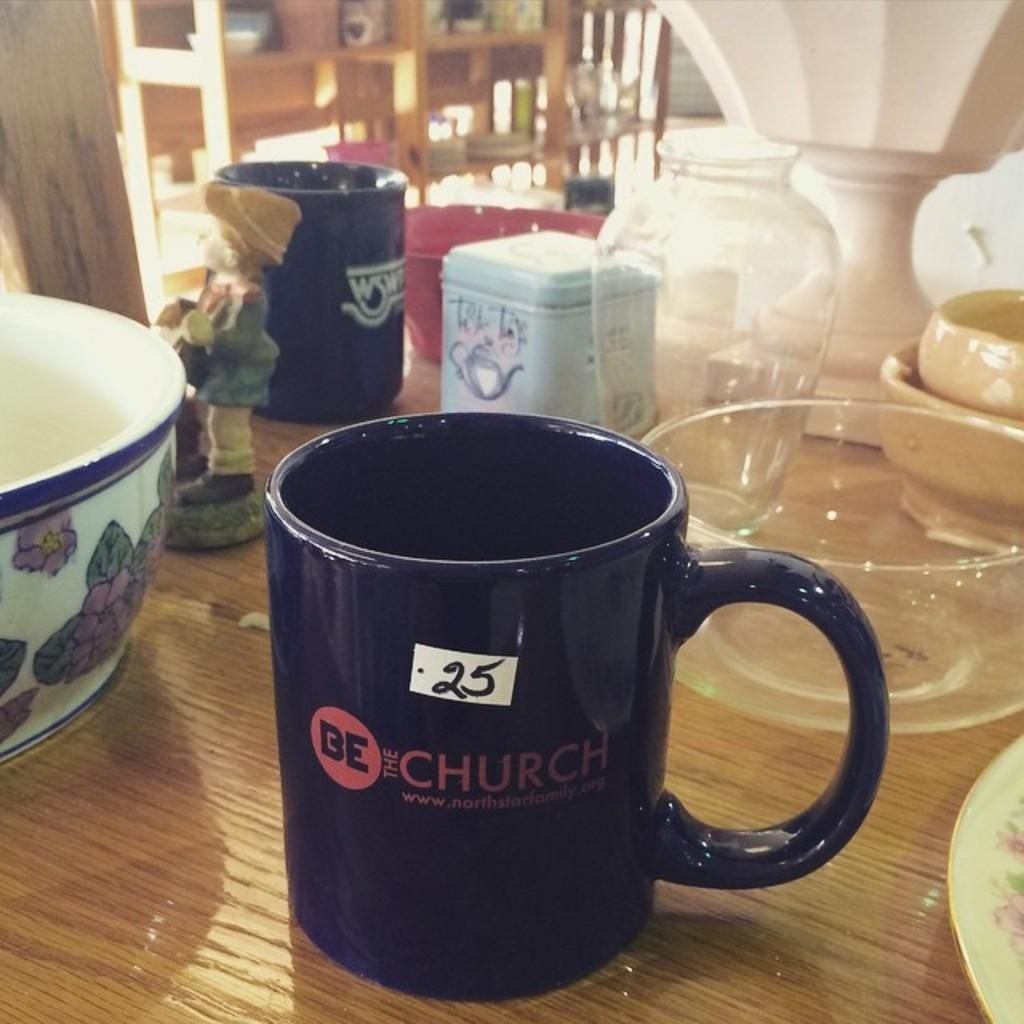<image>
Render a clear and concise summary of the photo. A mug that says BE Church on a wooden table with many other kitchen wares on it. 